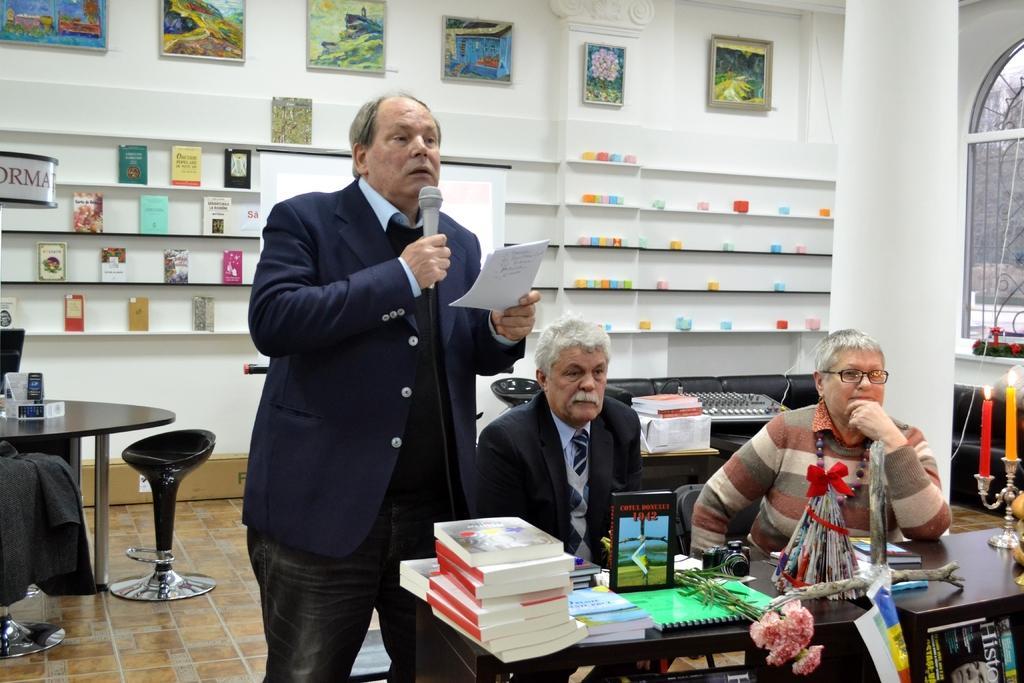Describe this image in one or two sentences. In this picture we can see a man holding a paper, mic with his hands, standing on the floor, two people sitting on chairs and in front of them on the tables we can see a camera, books, flowers, candle stand and in the background we can see a sofa, chairs, table, books on shelves, frames on the wall, pillar, window, some objects. 